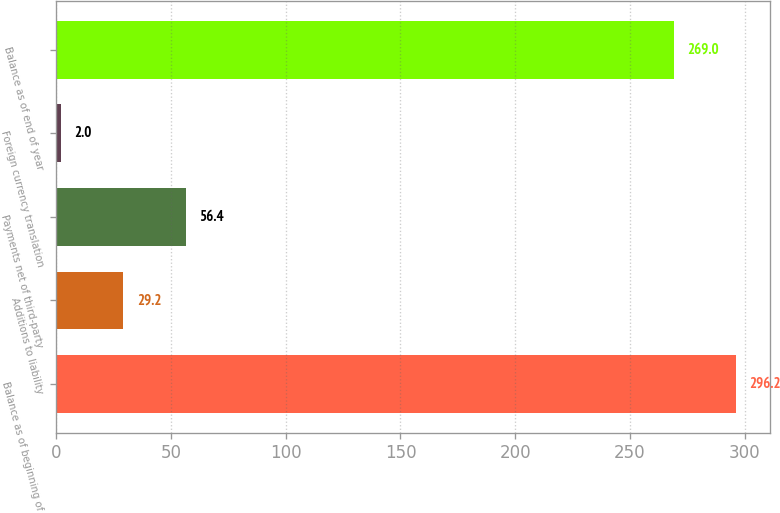Convert chart to OTSL. <chart><loc_0><loc_0><loc_500><loc_500><bar_chart><fcel>Balance as of beginning of<fcel>Additions to liability<fcel>Payments net of third-party<fcel>Foreign currency translation<fcel>Balance as of end of year<nl><fcel>296.2<fcel>29.2<fcel>56.4<fcel>2<fcel>269<nl></chart> 